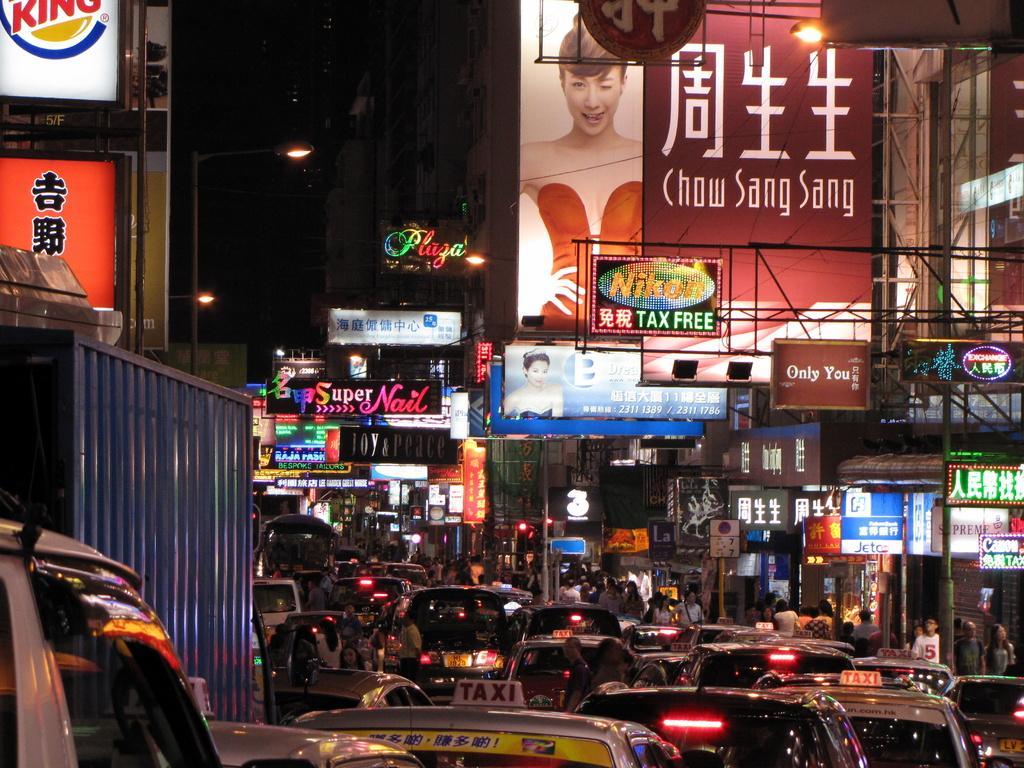How would you summarize this image in a sentence or two? This picture is clicked outside the city. At the bottom of the picture, we see many vehicles moving on the road. On either side of the picture, there are buildings and street lights. On the right side, we see a board with some text written on it. In the background, there are many hoarding boards with some text written. In the background, it is black in color. This picture is clicked in the dark. 